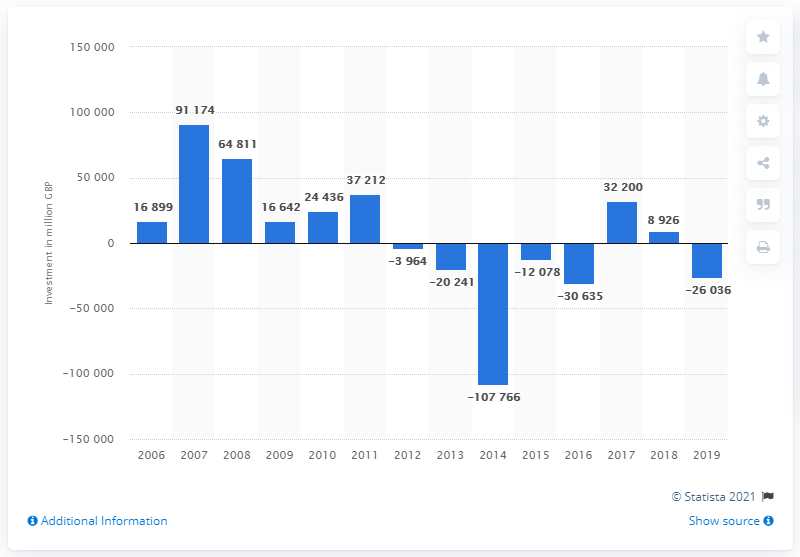Mention a couple of crucial points in this snapshot. In 2007, the net investment of UK companies into Europe was 91,174. In 2007, net investment reached its peak. 